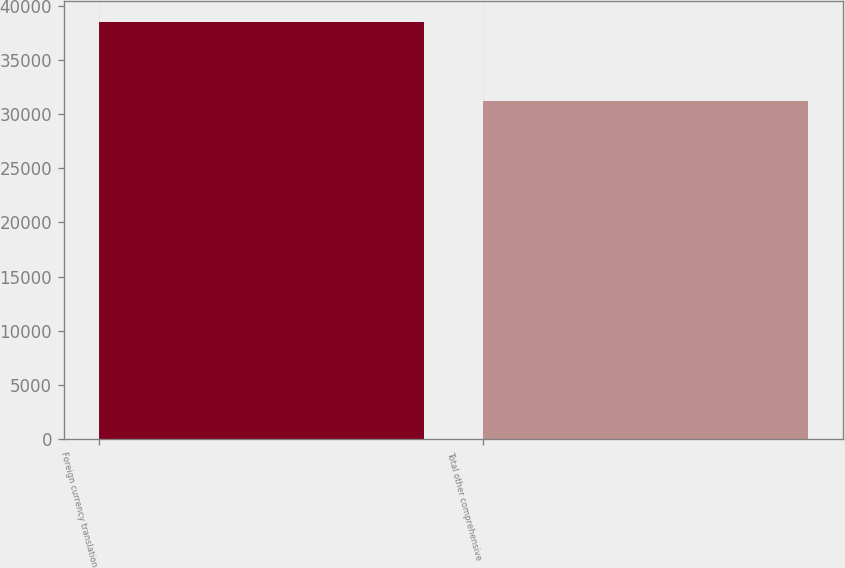Convert chart to OTSL. <chart><loc_0><loc_0><loc_500><loc_500><bar_chart><fcel>Foreign currency translation<fcel>Total other comprehensive<nl><fcel>38521<fcel>31234<nl></chart> 